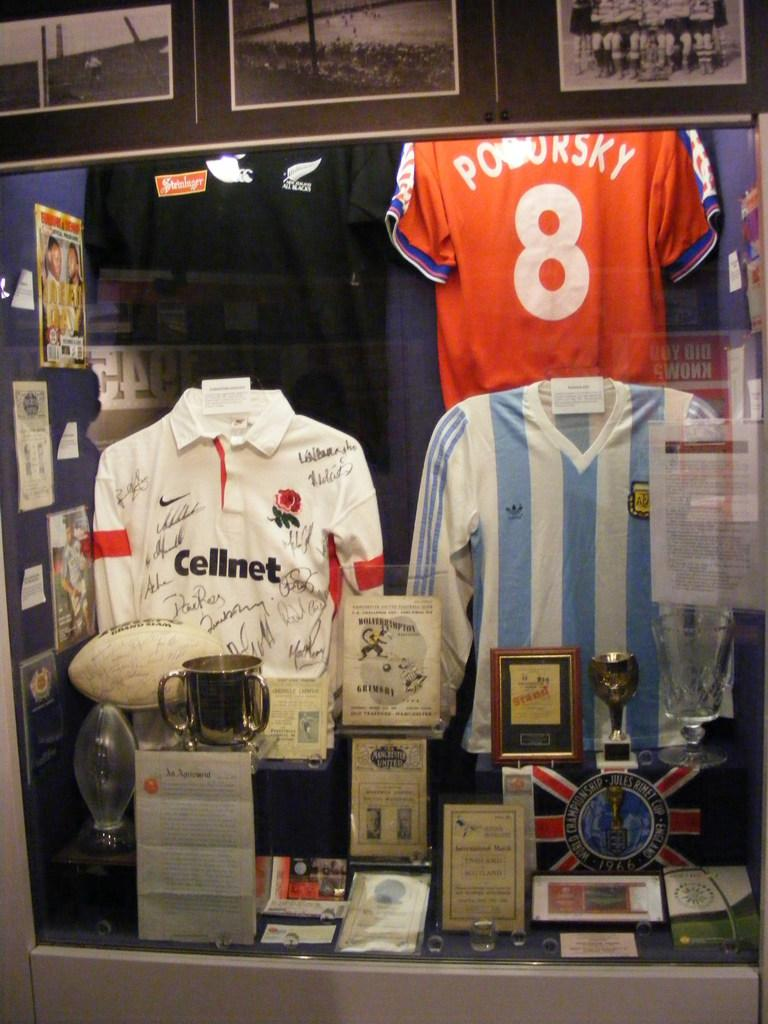<image>
Describe the image concisely. A display of football shirts, one of which is advertising Cellnet. 